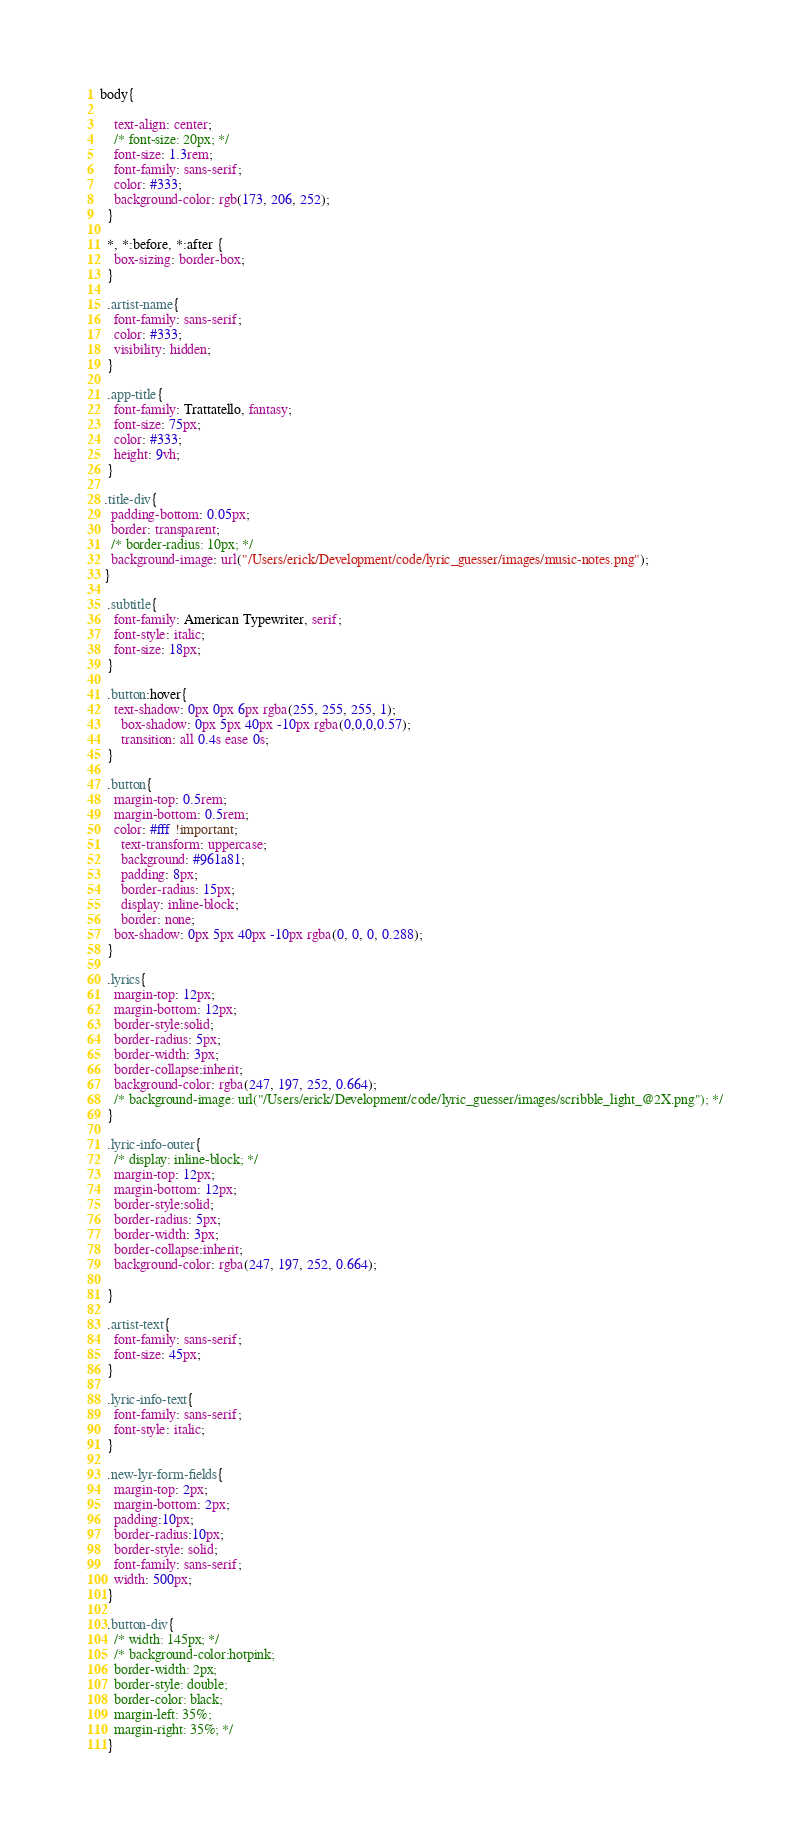Convert code to text. <code><loc_0><loc_0><loc_500><loc_500><_CSS_>body{
    
    text-align: center;
    /* font-size: 20px; */
    font-size: 1.3rem;
    font-family: sans-serif;
    color: #333;
    background-color: rgb(173, 206, 252);
  }

  *, *:before, *:after {
    box-sizing: border-box;
  }

  .artist-name{
    font-family: sans-serif;
    color: #333;
    visibility: hidden;
  }

  .app-title{
    font-family: Trattatello, fantasy;
    font-size: 75px;
    color: #333;
    height: 9vh; 
  }
  
 .title-div{
   padding-bottom: 0.05px;
   border: transparent;
   /* border-radius: 10px; */
   background-image: url("/Users/erick/Development/code/lyric_guesser/images/music-notes.png");
 }

  .subtitle{
    font-family: American Typewriter, serif;
    font-style: italic;
    font-size: 18px;
  }

  .button:hover{
    text-shadow: 0px 0px 6px rgba(255, 255, 255, 1);
	  box-shadow: 0px 5px 40px -10px rgba(0,0,0,0.57);
	  transition: all 0.4s ease 0s;
  }

  .button{
    margin-top: 0.5rem;
    margin-bottom: 0.5rem;
    color: #fff !important;
	  text-transform: uppercase;
	  background: #961a81;
	  padding: 8px;
	  border-radius: 15px;
	  display: inline-block;
	  border: none;
    box-shadow: 0px 5px 40px -10px rgba(0, 0, 0, 0.288);
  }

  .lyrics{
    margin-top: 12px;
    margin-bottom: 12px;
    border-style:solid;
    border-radius: 5px;
    border-width: 3px;
    border-collapse:inherit;
    background-color: rgba(247, 197, 252, 0.664);
    /* background-image: url("/Users/erick/Development/code/lyric_guesser/images/scribble_light_@2X.png"); */
  }

  .lyric-info-outer{
    /* display: inline-block; */
    margin-top: 12px;
    margin-bottom: 12px;
    border-style:solid;
    border-radius: 5px;
    border-width: 3px;
    border-collapse:inherit;
    background-color: rgba(247, 197, 252, 0.664);
    
  }

  .artist-text{
    font-family: sans-serif;
    font-size: 45px;
  }

  .lyric-info-text{
    font-family: sans-serif;
    font-style: italic;
  }

  .new-lyr-form-fields{
    margin-top: 2px;
    margin-bottom: 2px;
    padding:10px;
    border-radius:10px;
    border-style: solid;
    font-family: sans-serif;
    width: 500px;
  }

  .button-div{
    /* width: 145px; */
    /* background-color:hotpink;
    border-width: 2px;
    border-style: double;
    border-color: black;
    margin-left: 35%;
    margin-right: 35%; */
  }
</code> 